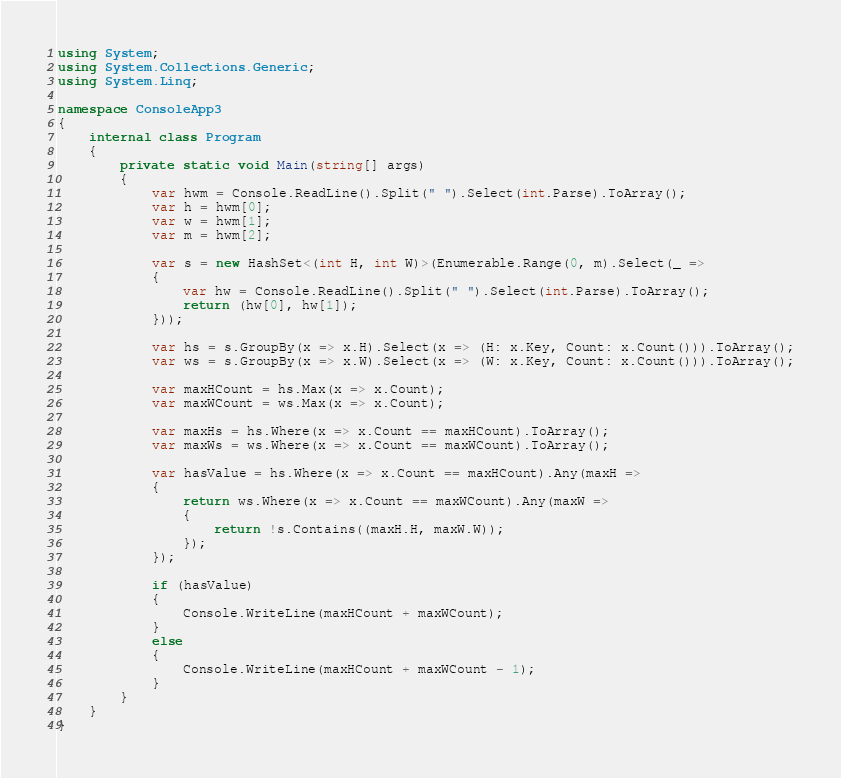Convert code to text. <code><loc_0><loc_0><loc_500><loc_500><_C#_>using System;
using System.Collections.Generic;
using System.Linq;

namespace ConsoleApp3
{
    internal class Program
    {
        private static void Main(string[] args)
        {
            var hwm = Console.ReadLine().Split(" ").Select(int.Parse).ToArray();
            var h = hwm[0];
            var w = hwm[1];
            var m = hwm[2];

            var s = new HashSet<(int H, int W)>(Enumerable.Range(0, m).Select(_ =>
            {
                var hw = Console.ReadLine().Split(" ").Select(int.Parse).ToArray();
                return (hw[0], hw[1]);
            }));

            var hs = s.GroupBy(x => x.H).Select(x => (H: x.Key, Count: x.Count())).ToArray();
            var ws = s.GroupBy(x => x.W).Select(x => (W: x.Key, Count: x.Count())).ToArray();

            var maxHCount = hs.Max(x => x.Count);
            var maxWCount = ws.Max(x => x.Count);

            var maxHs = hs.Where(x => x.Count == maxHCount).ToArray();
            var maxWs = ws.Where(x => x.Count == maxWCount).ToArray();

            var hasValue = hs.Where(x => x.Count == maxHCount).Any(maxH =>
            {
                return ws.Where(x => x.Count == maxWCount).Any(maxW =>
                {
                    return !s.Contains((maxH.H, maxW.W));
                });
            });

            if (hasValue)
            {
                Console.WriteLine(maxHCount + maxWCount);
            }
            else
            {
                Console.WriteLine(maxHCount + maxWCount - 1);
            }
        }
    }
}</code> 